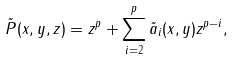Convert formula to latex. <formula><loc_0><loc_0><loc_500><loc_500>\tilde { P } ( x , y , z ) = z ^ { p } + \sum _ { i = 2 } ^ { p } \tilde { a } _ { i } ( x , y ) z ^ { p - i } ,</formula> 